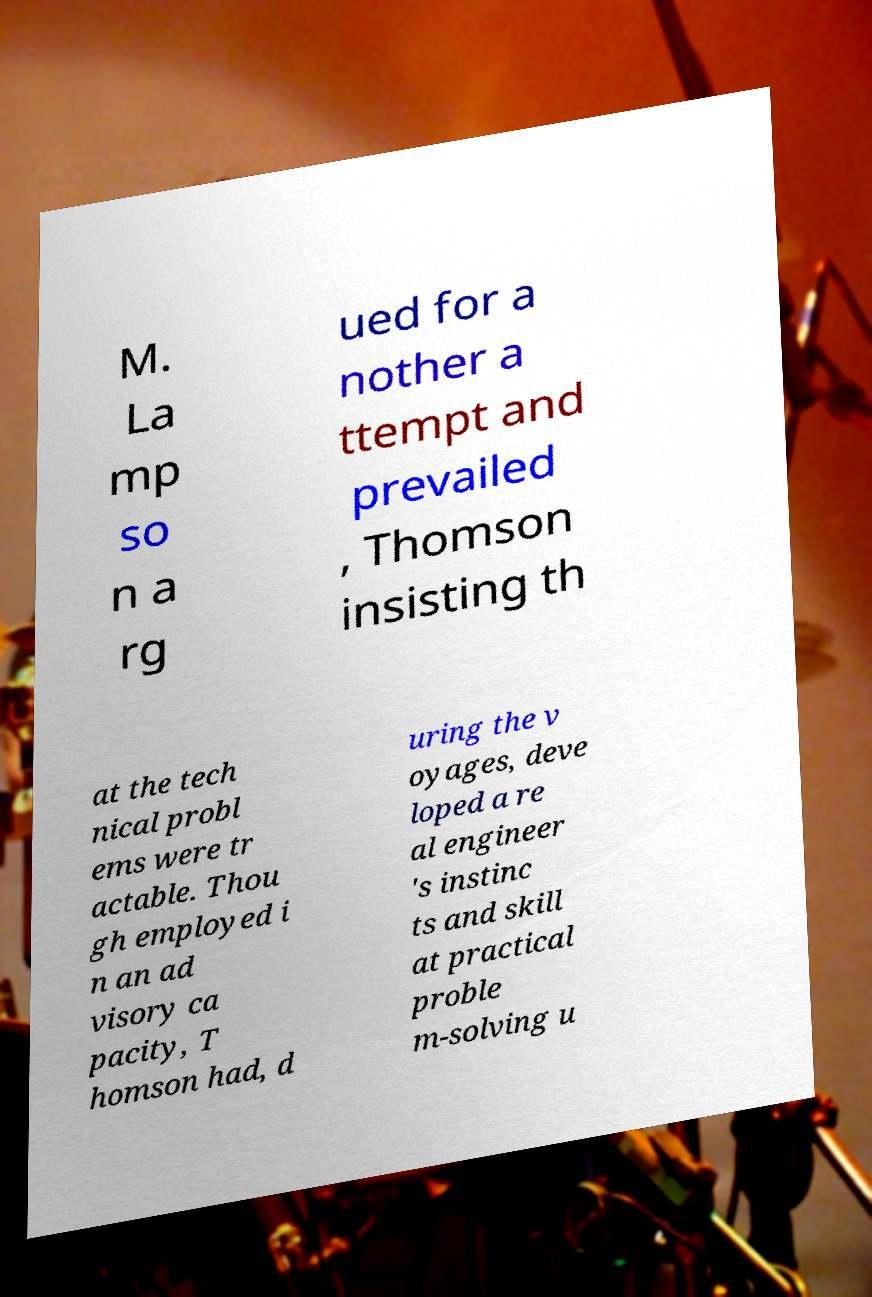I need the written content from this picture converted into text. Can you do that? M. La mp so n a rg ued for a nother a ttempt and prevailed , Thomson insisting th at the tech nical probl ems were tr actable. Thou gh employed i n an ad visory ca pacity, T homson had, d uring the v oyages, deve loped a re al engineer 's instinc ts and skill at practical proble m-solving u 